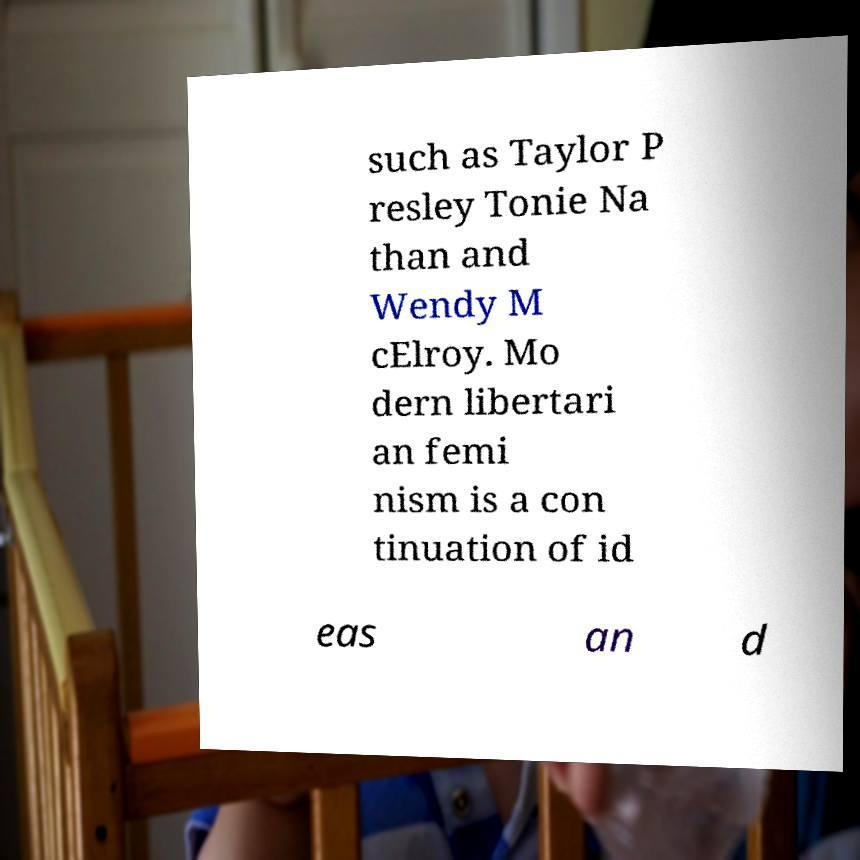Please read and relay the text visible in this image. What does it say? such as Taylor P resley Tonie Na than and Wendy M cElroy. Mo dern libertari an femi nism is a con tinuation of id eas an d 